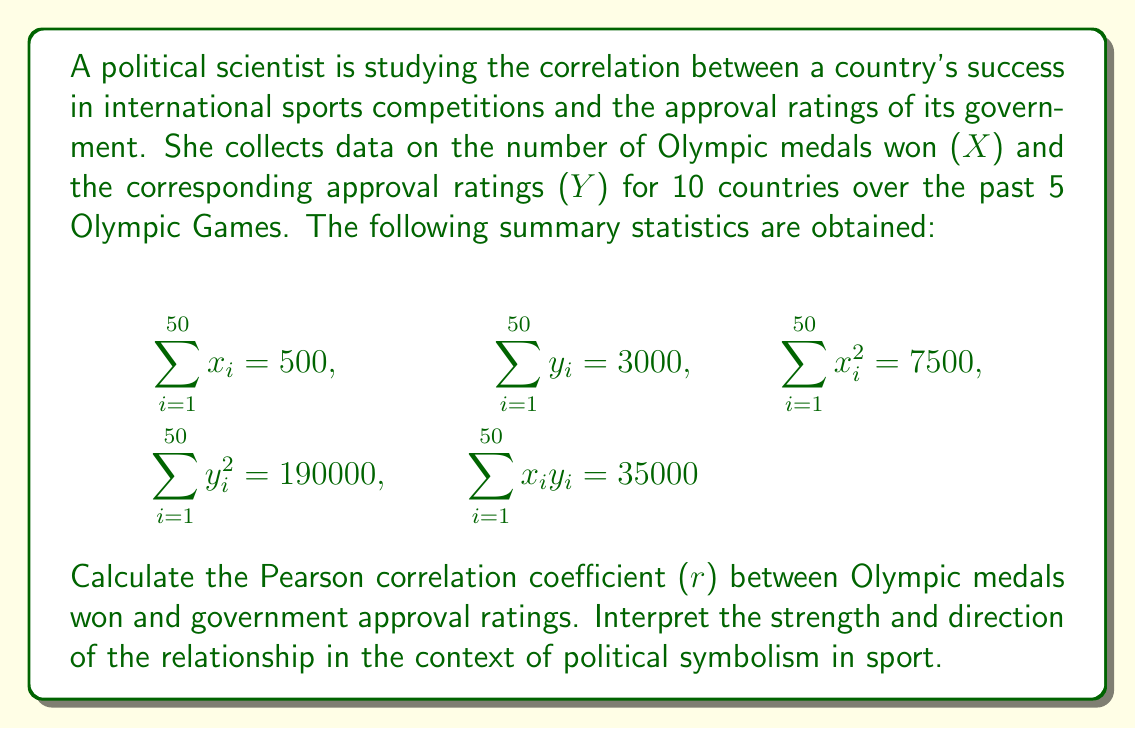Provide a solution to this math problem. To calculate the Pearson correlation coefficient (r), we'll use the formula:

$$r = \frac{n\sum xy - \sum x \sum y}{\sqrt{[n\sum x^2 - (\sum x)^2][n\sum y^2 - (\sum y)^2]}}$$

Where:
n = number of data points (50)
Σx = sum of X values (500)
Σy = sum of Y values (3000)
Σx² = sum of squared X values (7500)
Σy² = sum of squared Y values (190000)
Σxy = sum of products of X and Y (35000)

Step 1: Calculate the numerator
$$n\sum xy - \sum x \sum y = 50(35000) - 500(3000) = 250000$$

Step 2: Calculate the first part of the denominator
$$n\sum x^2 - (\sum x)^2 = 50(7500) - 500^2 = 125000$$

Step 3: Calculate the second part of the denominator
$$n\sum y^2 - (\sum y)^2 = 50(190000) - 3000^2 = 500000$$

Step 4: Multiply the two parts of the denominator and take the square root
$$\sqrt{125000 \times 500000} = 250000$$

Step 5: Divide the numerator by the denominator
$$r = \frac{250000}{250000} = 1$$

Interpretation: The Pearson correlation coefficient of 1 indicates a perfect positive correlation between Olympic medals won and government approval ratings. In the context of political symbolism in sport, this suggests that national sports success is strongly associated with increased political approval. This perfect correlation might imply that governments effectively use sports achievements as a symbol of national pride and competence, potentially influencing public opinion and approval ratings.
Answer: $r = 1$, perfect positive correlation 